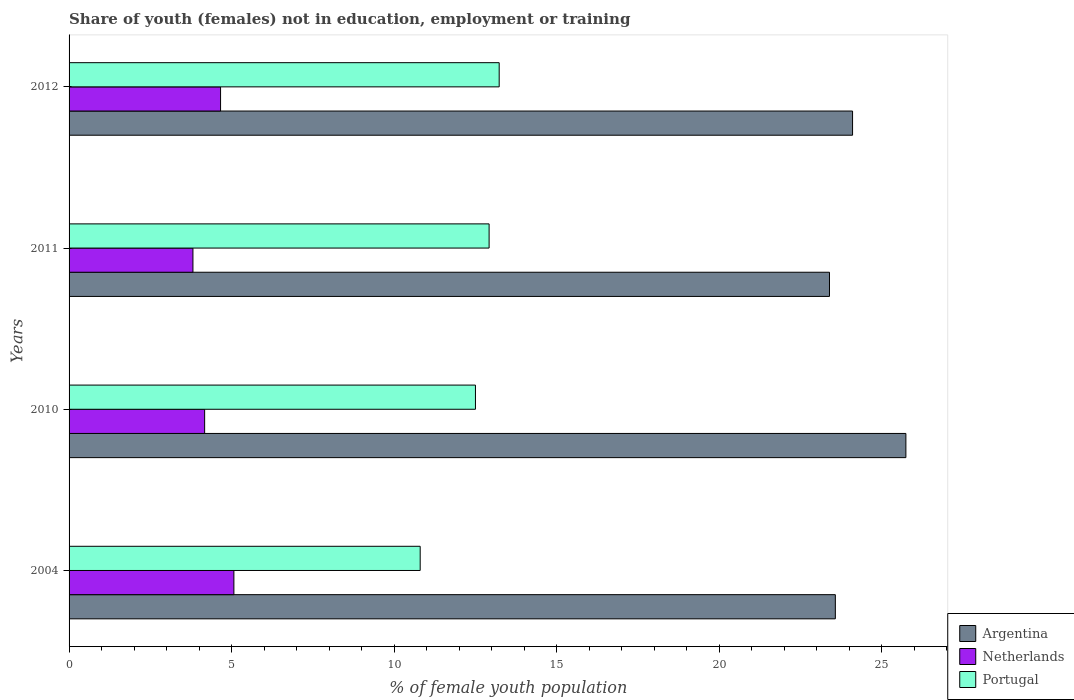How many different coloured bars are there?
Make the answer very short. 3. How many groups of bars are there?
Your response must be concise. 4. Are the number of bars per tick equal to the number of legend labels?
Your answer should be very brief. Yes. Are the number of bars on each tick of the Y-axis equal?
Provide a succinct answer. Yes. How many bars are there on the 2nd tick from the bottom?
Offer a terse response. 3. What is the percentage of unemployed female population in in Portugal in 2011?
Your answer should be compact. 12.92. Across all years, what is the maximum percentage of unemployed female population in in Argentina?
Keep it short and to the point. 25.74. Across all years, what is the minimum percentage of unemployed female population in in Netherlands?
Make the answer very short. 3.81. In which year was the percentage of unemployed female population in in Netherlands minimum?
Provide a short and direct response. 2011. What is the total percentage of unemployed female population in in Portugal in the graph?
Provide a short and direct response. 49.45. What is the difference between the percentage of unemployed female population in in Portugal in 2004 and that in 2012?
Keep it short and to the point. -2.43. What is the difference between the percentage of unemployed female population in in Netherlands in 2004 and the percentage of unemployed female population in in Argentina in 2011?
Your answer should be compact. -18.32. What is the average percentage of unemployed female population in in Netherlands per year?
Provide a succinct answer. 4.43. In the year 2010, what is the difference between the percentage of unemployed female population in in Portugal and percentage of unemployed female population in in Argentina?
Offer a terse response. -13.24. In how many years, is the percentage of unemployed female population in in Argentina greater than 18 %?
Give a very brief answer. 4. What is the ratio of the percentage of unemployed female population in in Netherlands in 2011 to that in 2012?
Give a very brief answer. 0.82. Is the percentage of unemployed female population in in Argentina in 2010 less than that in 2012?
Provide a short and direct response. No. What is the difference between the highest and the second highest percentage of unemployed female population in in Argentina?
Ensure brevity in your answer.  1.64. What is the difference between the highest and the lowest percentage of unemployed female population in in Argentina?
Offer a very short reply. 2.35. Is the sum of the percentage of unemployed female population in in Portugal in 2004 and 2012 greater than the maximum percentage of unemployed female population in in Argentina across all years?
Provide a short and direct response. No. What does the 2nd bar from the top in 2010 represents?
Keep it short and to the point. Netherlands. How many bars are there?
Your answer should be very brief. 12. What is the difference between two consecutive major ticks on the X-axis?
Keep it short and to the point. 5. Does the graph contain any zero values?
Your answer should be very brief. No. Does the graph contain grids?
Provide a short and direct response. No. What is the title of the graph?
Offer a terse response. Share of youth (females) not in education, employment or training. What is the label or title of the X-axis?
Give a very brief answer. % of female youth population. What is the label or title of the Y-axis?
Give a very brief answer. Years. What is the % of female youth population of Argentina in 2004?
Provide a succinct answer. 23.57. What is the % of female youth population of Netherlands in 2004?
Ensure brevity in your answer.  5.07. What is the % of female youth population of Portugal in 2004?
Make the answer very short. 10.8. What is the % of female youth population of Argentina in 2010?
Your response must be concise. 25.74. What is the % of female youth population of Netherlands in 2010?
Ensure brevity in your answer.  4.17. What is the % of female youth population in Portugal in 2010?
Keep it short and to the point. 12.5. What is the % of female youth population of Argentina in 2011?
Provide a succinct answer. 23.39. What is the % of female youth population of Netherlands in 2011?
Offer a very short reply. 3.81. What is the % of female youth population of Portugal in 2011?
Provide a succinct answer. 12.92. What is the % of female youth population in Argentina in 2012?
Your answer should be compact. 24.1. What is the % of female youth population of Netherlands in 2012?
Your answer should be very brief. 4.66. What is the % of female youth population in Portugal in 2012?
Your response must be concise. 13.23. Across all years, what is the maximum % of female youth population in Argentina?
Ensure brevity in your answer.  25.74. Across all years, what is the maximum % of female youth population of Netherlands?
Provide a succinct answer. 5.07. Across all years, what is the maximum % of female youth population in Portugal?
Offer a terse response. 13.23. Across all years, what is the minimum % of female youth population of Argentina?
Your response must be concise. 23.39. Across all years, what is the minimum % of female youth population in Netherlands?
Your response must be concise. 3.81. Across all years, what is the minimum % of female youth population of Portugal?
Make the answer very short. 10.8. What is the total % of female youth population in Argentina in the graph?
Offer a very short reply. 96.8. What is the total % of female youth population of Netherlands in the graph?
Make the answer very short. 17.71. What is the total % of female youth population in Portugal in the graph?
Make the answer very short. 49.45. What is the difference between the % of female youth population of Argentina in 2004 and that in 2010?
Provide a succinct answer. -2.17. What is the difference between the % of female youth population of Argentina in 2004 and that in 2011?
Provide a succinct answer. 0.18. What is the difference between the % of female youth population in Netherlands in 2004 and that in 2011?
Your answer should be very brief. 1.26. What is the difference between the % of female youth population in Portugal in 2004 and that in 2011?
Provide a short and direct response. -2.12. What is the difference between the % of female youth population in Argentina in 2004 and that in 2012?
Keep it short and to the point. -0.53. What is the difference between the % of female youth population of Netherlands in 2004 and that in 2012?
Provide a short and direct response. 0.41. What is the difference between the % of female youth population in Portugal in 2004 and that in 2012?
Your answer should be very brief. -2.43. What is the difference between the % of female youth population of Argentina in 2010 and that in 2011?
Provide a short and direct response. 2.35. What is the difference between the % of female youth population in Netherlands in 2010 and that in 2011?
Keep it short and to the point. 0.36. What is the difference between the % of female youth population in Portugal in 2010 and that in 2011?
Your answer should be very brief. -0.42. What is the difference between the % of female youth population of Argentina in 2010 and that in 2012?
Provide a short and direct response. 1.64. What is the difference between the % of female youth population in Netherlands in 2010 and that in 2012?
Offer a very short reply. -0.49. What is the difference between the % of female youth population in Portugal in 2010 and that in 2012?
Your answer should be very brief. -0.73. What is the difference between the % of female youth population of Argentina in 2011 and that in 2012?
Offer a terse response. -0.71. What is the difference between the % of female youth population of Netherlands in 2011 and that in 2012?
Give a very brief answer. -0.85. What is the difference between the % of female youth population of Portugal in 2011 and that in 2012?
Your answer should be very brief. -0.31. What is the difference between the % of female youth population of Argentina in 2004 and the % of female youth population of Netherlands in 2010?
Offer a terse response. 19.4. What is the difference between the % of female youth population of Argentina in 2004 and the % of female youth population of Portugal in 2010?
Keep it short and to the point. 11.07. What is the difference between the % of female youth population in Netherlands in 2004 and the % of female youth population in Portugal in 2010?
Your answer should be compact. -7.43. What is the difference between the % of female youth population of Argentina in 2004 and the % of female youth population of Netherlands in 2011?
Offer a terse response. 19.76. What is the difference between the % of female youth population of Argentina in 2004 and the % of female youth population of Portugal in 2011?
Give a very brief answer. 10.65. What is the difference between the % of female youth population of Netherlands in 2004 and the % of female youth population of Portugal in 2011?
Your answer should be compact. -7.85. What is the difference between the % of female youth population in Argentina in 2004 and the % of female youth population in Netherlands in 2012?
Offer a terse response. 18.91. What is the difference between the % of female youth population in Argentina in 2004 and the % of female youth population in Portugal in 2012?
Your response must be concise. 10.34. What is the difference between the % of female youth population in Netherlands in 2004 and the % of female youth population in Portugal in 2012?
Your response must be concise. -8.16. What is the difference between the % of female youth population of Argentina in 2010 and the % of female youth population of Netherlands in 2011?
Offer a terse response. 21.93. What is the difference between the % of female youth population in Argentina in 2010 and the % of female youth population in Portugal in 2011?
Provide a short and direct response. 12.82. What is the difference between the % of female youth population of Netherlands in 2010 and the % of female youth population of Portugal in 2011?
Keep it short and to the point. -8.75. What is the difference between the % of female youth population in Argentina in 2010 and the % of female youth population in Netherlands in 2012?
Give a very brief answer. 21.08. What is the difference between the % of female youth population in Argentina in 2010 and the % of female youth population in Portugal in 2012?
Your answer should be very brief. 12.51. What is the difference between the % of female youth population of Netherlands in 2010 and the % of female youth population of Portugal in 2012?
Your answer should be compact. -9.06. What is the difference between the % of female youth population of Argentina in 2011 and the % of female youth population of Netherlands in 2012?
Offer a very short reply. 18.73. What is the difference between the % of female youth population in Argentina in 2011 and the % of female youth population in Portugal in 2012?
Provide a succinct answer. 10.16. What is the difference between the % of female youth population of Netherlands in 2011 and the % of female youth population of Portugal in 2012?
Make the answer very short. -9.42. What is the average % of female youth population in Argentina per year?
Offer a terse response. 24.2. What is the average % of female youth population of Netherlands per year?
Your answer should be compact. 4.43. What is the average % of female youth population in Portugal per year?
Offer a terse response. 12.36. In the year 2004, what is the difference between the % of female youth population of Argentina and % of female youth population of Portugal?
Provide a short and direct response. 12.77. In the year 2004, what is the difference between the % of female youth population in Netherlands and % of female youth population in Portugal?
Keep it short and to the point. -5.73. In the year 2010, what is the difference between the % of female youth population in Argentina and % of female youth population in Netherlands?
Provide a succinct answer. 21.57. In the year 2010, what is the difference between the % of female youth population of Argentina and % of female youth population of Portugal?
Your answer should be compact. 13.24. In the year 2010, what is the difference between the % of female youth population of Netherlands and % of female youth population of Portugal?
Ensure brevity in your answer.  -8.33. In the year 2011, what is the difference between the % of female youth population in Argentina and % of female youth population in Netherlands?
Your response must be concise. 19.58. In the year 2011, what is the difference between the % of female youth population in Argentina and % of female youth population in Portugal?
Give a very brief answer. 10.47. In the year 2011, what is the difference between the % of female youth population of Netherlands and % of female youth population of Portugal?
Provide a succinct answer. -9.11. In the year 2012, what is the difference between the % of female youth population in Argentina and % of female youth population in Netherlands?
Provide a succinct answer. 19.44. In the year 2012, what is the difference between the % of female youth population in Argentina and % of female youth population in Portugal?
Your answer should be compact. 10.87. In the year 2012, what is the difference between the % of female youth population of Netherlands and % of female youth population of Portugal?
Provide a succinct answer. -8.57. What is the ratio of the % of female youth population of Argentina in 2004 to that in 2010?
Your response must be concise. 0.92. What is the ratio of the % of female youth population in Netherlands in 2004 to that in 2010?
Your answer should be very brief. 1.22. What is the ratio of the % of female youth population of Portugal in 2004 to that in 2010?
Provide a short and direct response. 0.86. What is the ratio of the % of female youth population of Argentina in 2004 to that in 2011?
Provide a succinct answer. 1.01. What is the ratio of the % of female youth population in Netherlands in 2004 to that in 2011?
Give a very brief answer. 1.33. What is the ratio of the % of female youth population in Portugal in 2004 to that in 2011?
Give a very brief answer. 0.84. What is the ratio of the % of female youth population in Argentina in 2004 to that in 2012?
Make the answer very short. 0.98. What is the ratio of the % of female youth population in Netherlands in 2004 to that in 2012?
Your answer should be very brief. 1.09. What is the ratio of the % of female youth population of Portugal in 2004 to that in 2012?
Provide a short and direct response. 0.82. What is the ratio of the % of female youth population of Argentina in 2010 to that in 2011?
Keep it short and to the point. 1.1. What is the ratio of the % of female youth population in Netherlands in 2010 to that in 2011?
Offer a terse response. 1.09. What is the ratio of the % of female youth population in Portugal in 2010 to that in 2011?
Ensure brevity in your answer.  0.97. What is the ratio of the % of female youth population of Argentina in 2010 to that in 2012?
Keep it short and to the point. 1.07. What is the ratio of the % of female youth population in Netherlands in 2010 to that in 2012?
Your answer should be compact. 0.89. What is the ratio of the % of female youth population in Portugal in 2010 to that in 2012?
Make the answer very short. 0.94. What is the ratio of the % of female youth population of Argentina in 2011 to that in 2012?
Provide a succinct answer. 0.97. What is the ratio of the % of female youth population of Netherlands in 2011 to that in 2012?
Provide a short and direct response. 0.82. What is the ratio of the % of female youth population of Portugal in 2011 to that in 2012?
Your answer should be very brief. 0.98. What is the difference between the highest and the second highest % of female youth population in Argentina?
Provide a short and direct response. 1.64. What is the difference between the highest and the second highest % of female youth population in Netherlands?
Your answer should be very brief. 0.41. What is the difference between the highest and the second highest % of female youth population in Portugal?
Offer a very short reply. 0.31. What is the difference between the highest and the lowest % of female youth population in Argentina?
Offer a terse response. 2.35. What is the difference between the highest and the lowest % of female youth population of Netherlands?
Give a very brief answer. 1.26. What is the difference between the highest and the lowest % of female youth population of Portugal?
Your response must be concise. 2.43. 